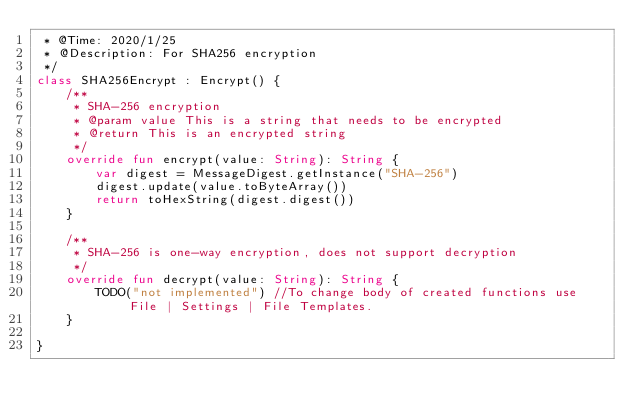Convert code to text. <code><loc_0><loc_0><loc_500><loc_500><_Kotlin_> * @Time: 2020/1/25
 * @Description: For SHA256 encryption
 */
class SHA256Encrypt : Encrypt() {
    /**
     * SHA-256 encryption
     * @param value This is a string that needs to be encrypted
     * @return This is an encrypted string
     */
    override fun encrypt(value: String): String {
        var digest = MessageDigest.getInstance("SHA-256")
        digest.update(value.toByteArray())
        return toHexString(digest.digest())
    }

    /**
     * SHA-256 is one-way encryption, does not support decryption
     */
    override fun decrypt(value: String): String {
        TODO("not implemented") //To change body of created functions use File | Settings | File Templates.
    }

}
</code> 